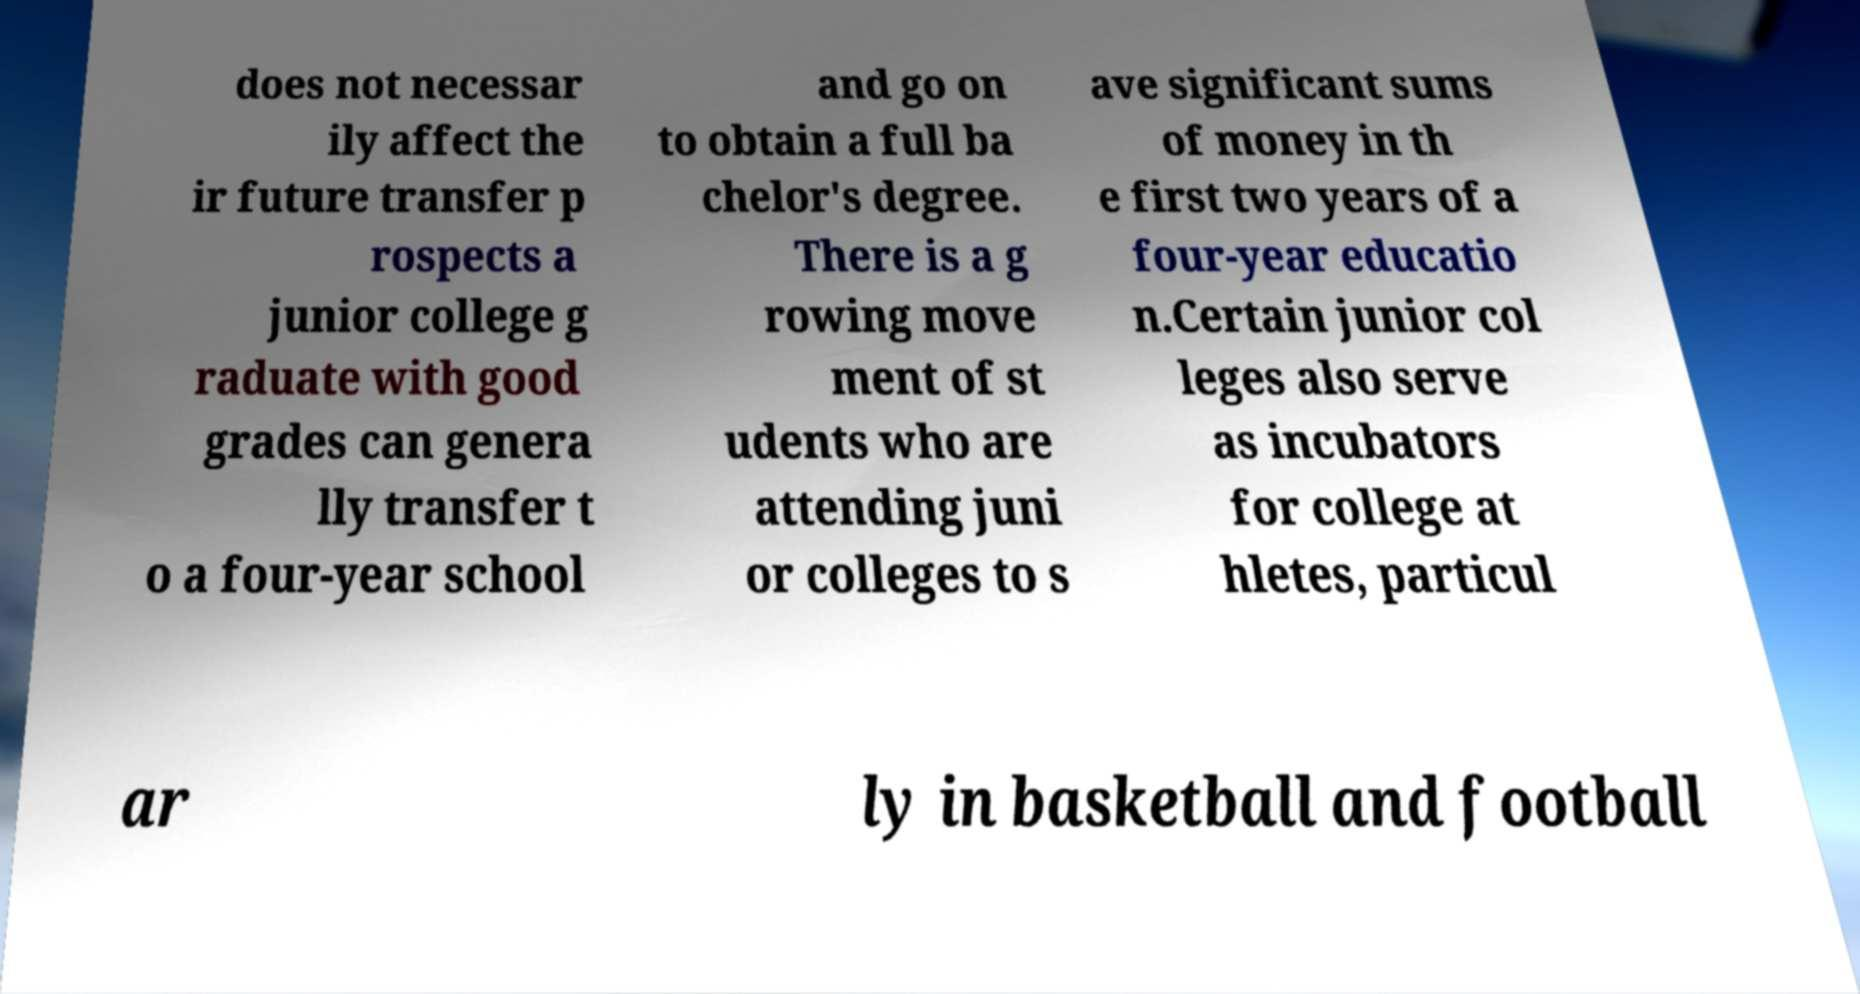Can you read and provide the text displayed in the image?This photo seems to have some interesting text. Can you extract and type it out for me? does not necessar ily affect the ir future transfer p rospects a junior college g raduate with good grades can genera lly transfer t o a four-year school and go on to obtain a full ba chelor's degree. There is a g rowing move ment of st udents who are attending juni or colleges to s ave significant sums of money in th e first two years of a four-year educatio n.Certain junior col leges also serve as incubators for college at hletes, particul ar ly in basketball and football 